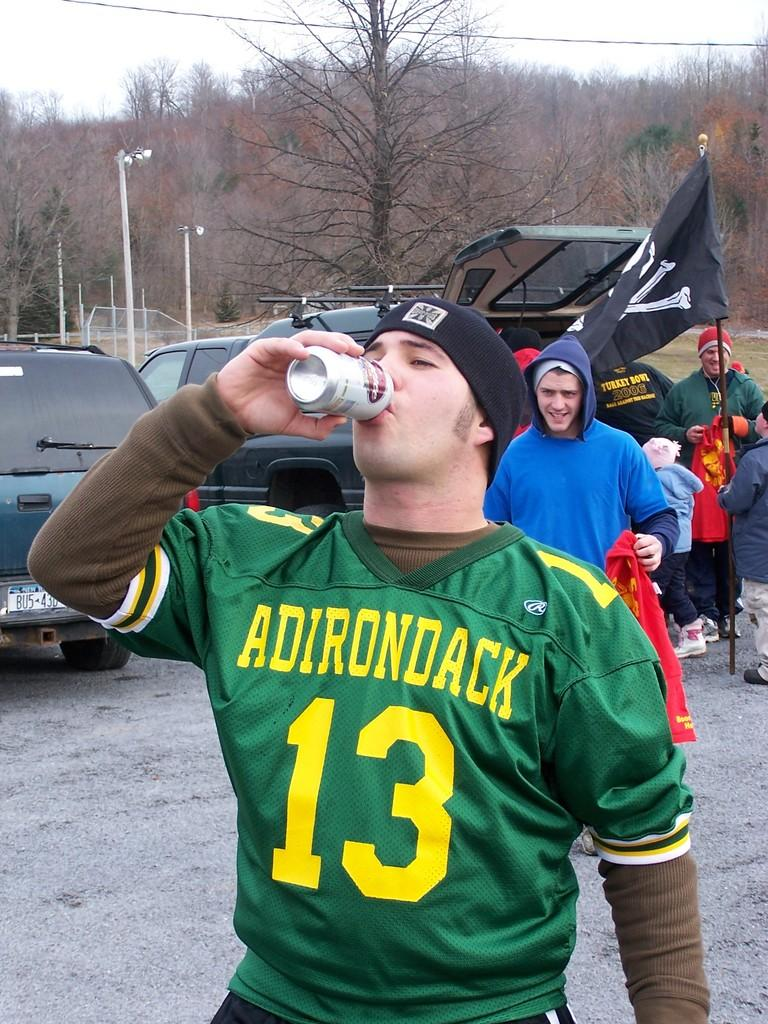<image>
Summarize the visual content of the image. A man wears a green jersey with the number 13 on it. 